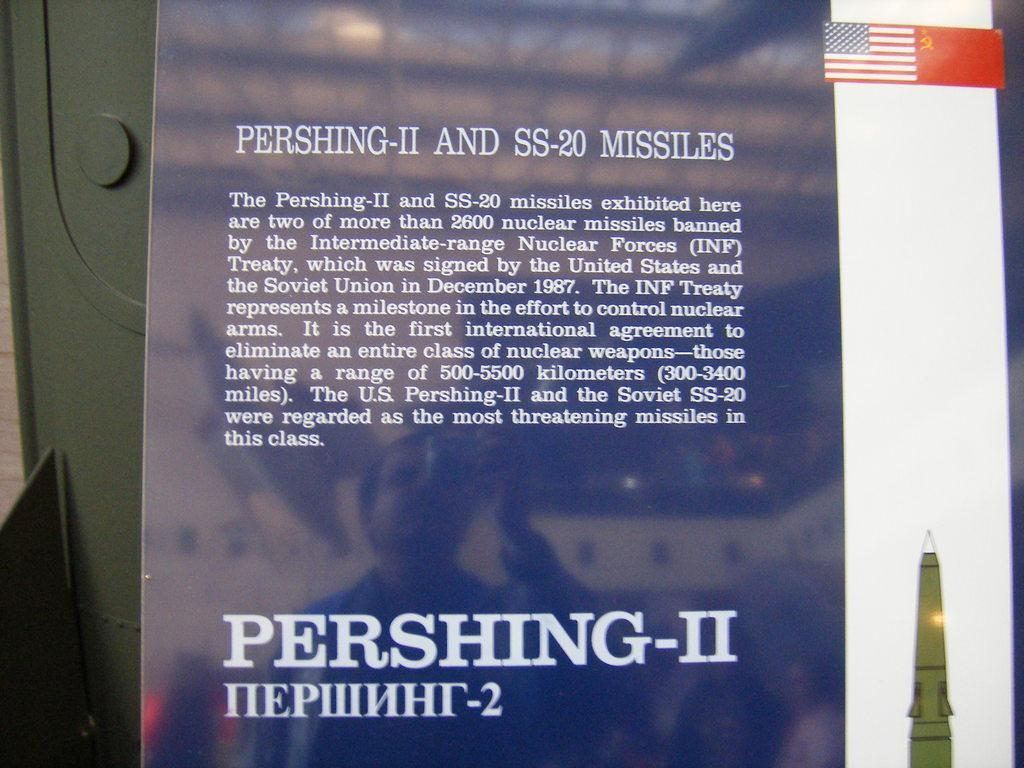<image>
Create a compact narrative representing the image presented. a page that is titled 'pershing-II and ss-20 missiles' 